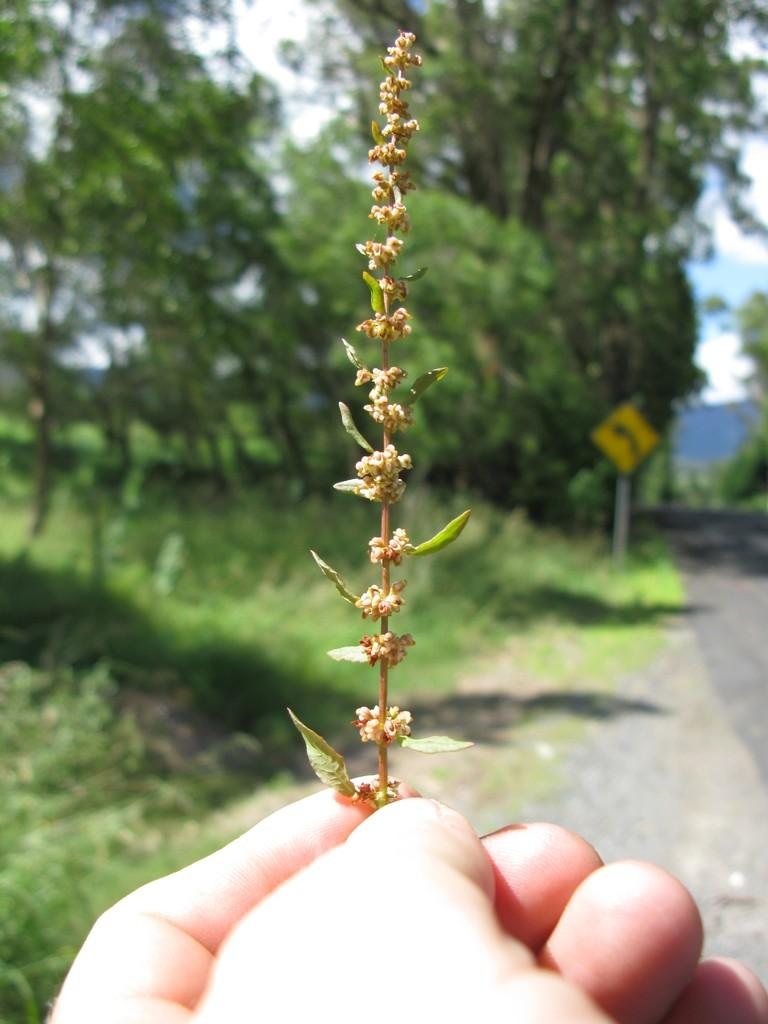What is the person in the image holding? The person is holding a plant in the image. How would you describe the background of the image? The background of the image is blurred. What type of natural environment can be seen in the image? There is ground with grass visible in the image, as well as trees. What man-made structures are present in the image? There is a road and a sign board with a pole in the image. What part of the natural environment is visible in the image? The sky is visible in the image. What type of stocking is the person wearing in the image? There is no information about the person's clothing, including stockings, in the image. How does the harmony between the person and the plant contribute to the overall aesthetic of the image? The image does not specifically address the concept of harmony between the person and the plant, so it is not possible to answer this question based on the provided facts. 